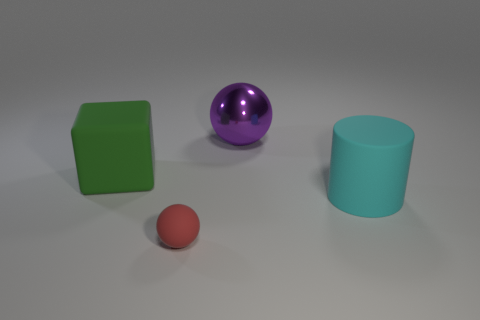Subtract all purple balls. How many balls are left? 1 Add 1 large cylinders. How many objects exist? 5 Subtract 0 gray balls. How many objects are left? 4 Subtract all cubes. How many objects are left? 3 Subtract all tiny green metal cylinders. Subtract all cyan cylinders. How many objects are left? 3 Add 1 big purple shiny balls. How many big purple shiny balls are left? 2 Add 3 tiny shiny cylinders. How many tiny shiny cylinders exist? 3 